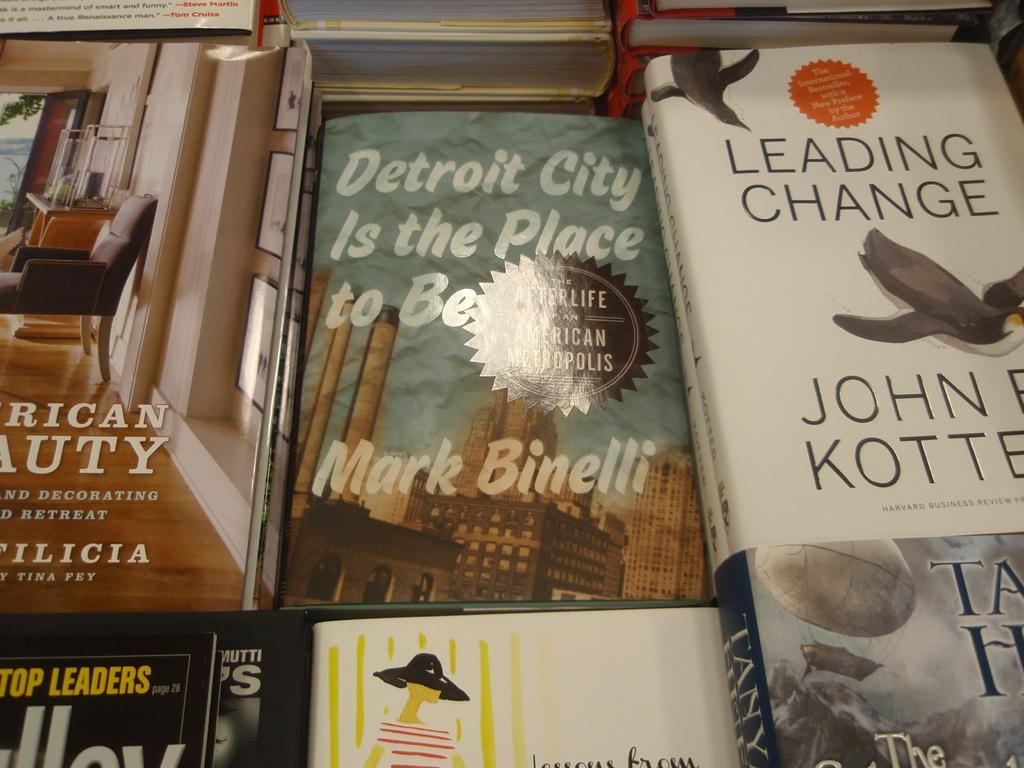<image>
Write a terse but informative summary of the picture. A collection of books includes the title Detroit City is the Place to be, by Mark Binelli. 